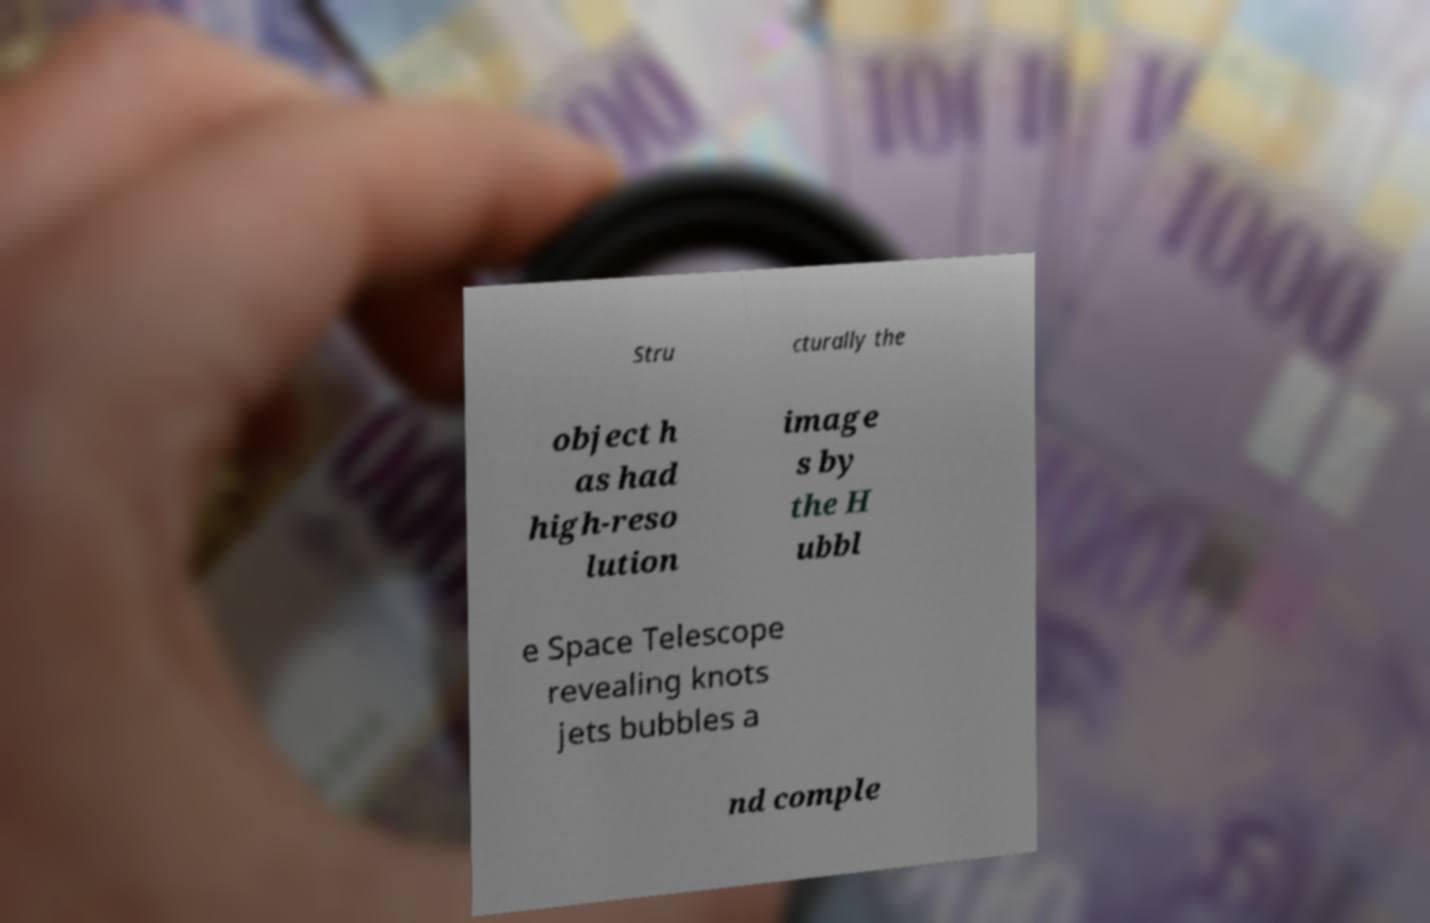For documentation purposes, I need the text within this image transcribed. Could you provide that? Stru cturally the object h as had high-reso lution image s by the H ubbl e Space Telescope revealing knots jets bubbles a nd comple 